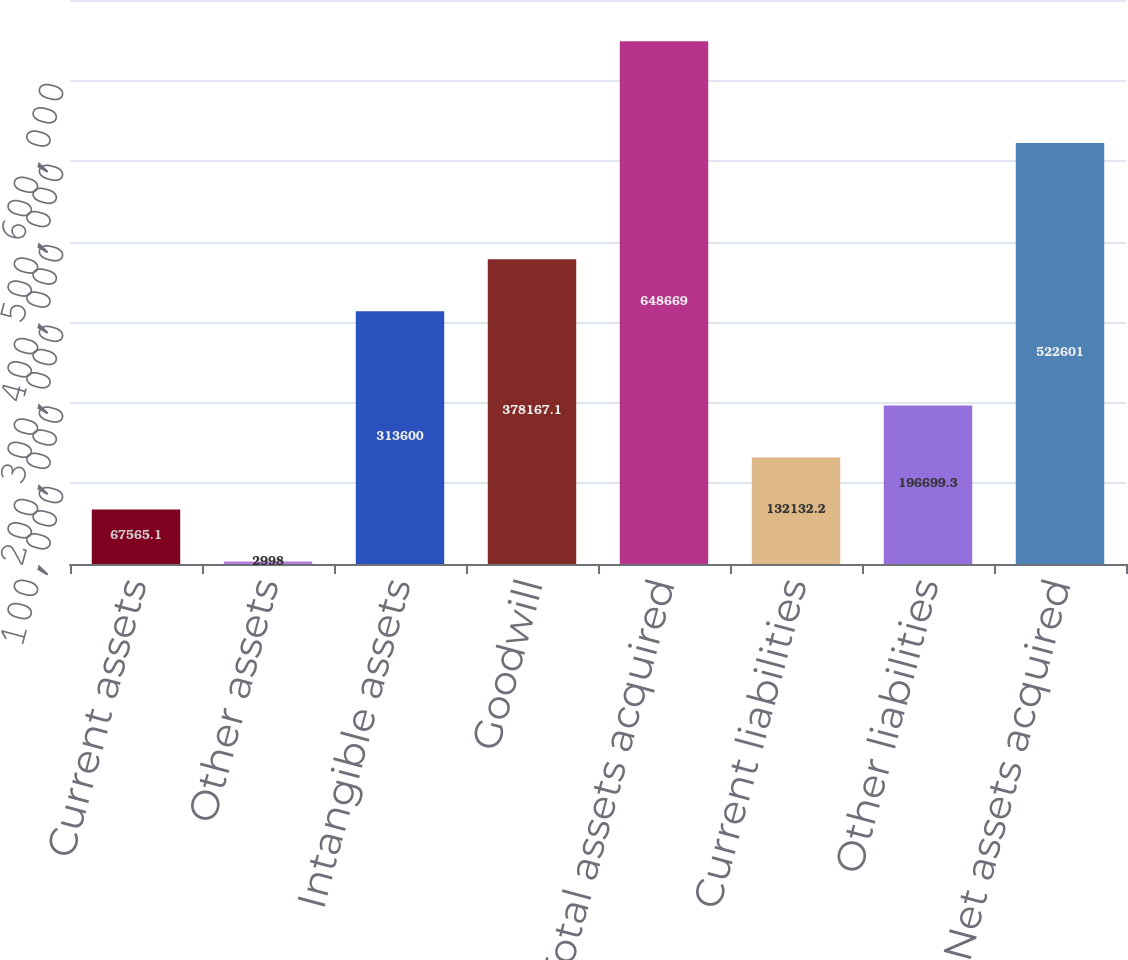Convert chart to OTSL. <chart><loc_0><loc_0><loc_500><loc_500><bar_chart><fcel>Current assets<fcel>Other assets<fcel>Intangible assets<fcel>Goodwill<fcel>Total assets acquired<fcel>Current liabilities<fcel>Other liabilities<fcel>Net assets acquired<nl><fcel>67565.1<fcel>2998<fcel>313600<fcel>378167<fcel>648669<fcel>132132<fcel>196699<fcel>522601<nl></chart> 